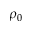Convert formula to latex. <formula><loc_0><loc_0><loc_500><loc_500>\rho _ { 0 }</formula> 